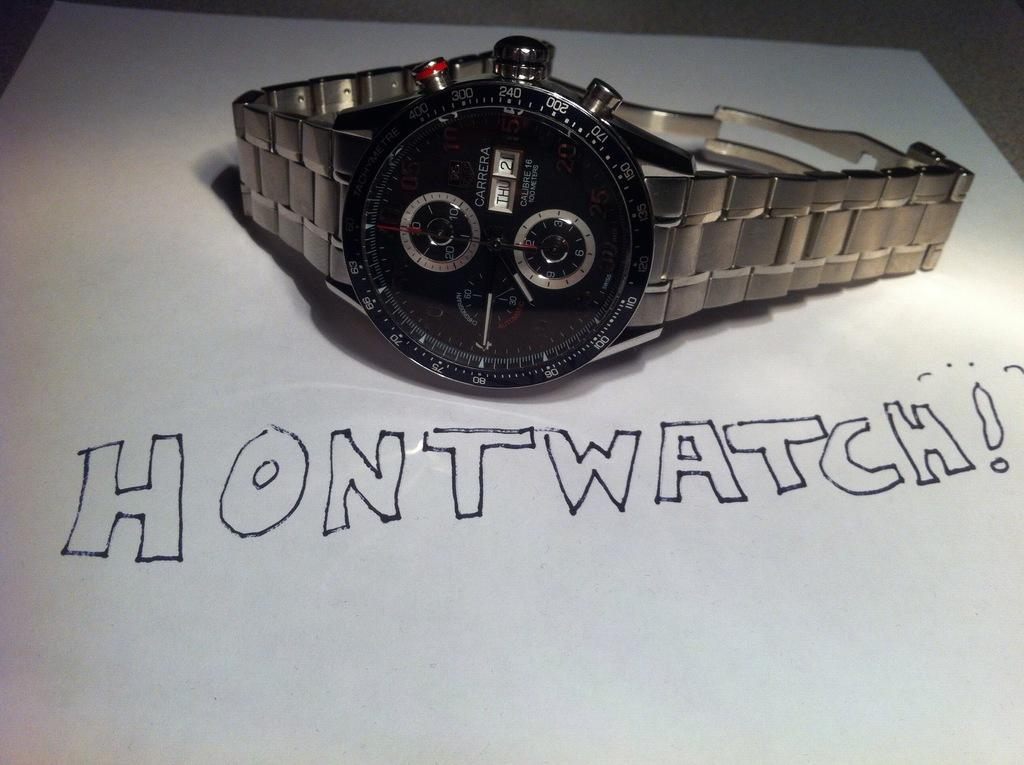Provide a one-sentence caption for the provided image. A wristwatch sitting on top of a piece of paper that says "hontwatch!". 